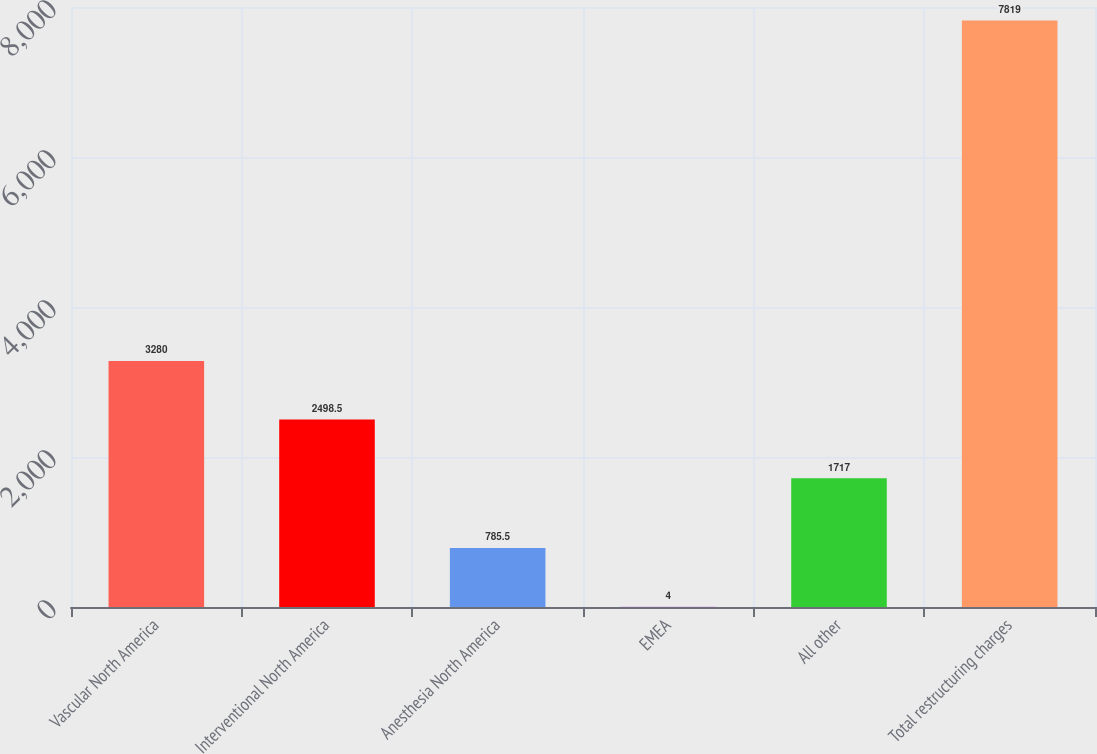Convert chart. <chart><loc_0><loc_0><loc_500><loc_500><bar_chart><fcel>Vascular North America<fcel>Interventional North America<fcel>Anesthesia North America<fcel>EMEA<fcel>All other<fcel>Total restructuring charges<nl><fcel>3280<fcel>2498.5<fcel>785.5<fcel>4<fcel>1717<fcel>7819<nl></chart> 